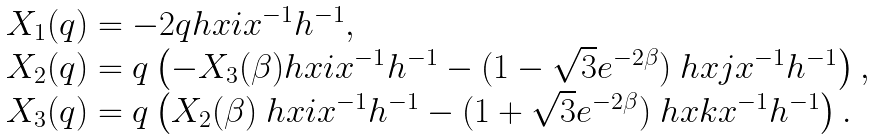<formula> <loc_0><loc_0><loc_500><loc_500>\begin{array} { l } X _ { 1 } ( q ) = - 2 q h x i x ^ { - 1 } h ^ { - 1 } , \\ X _ { 2 } ( q ) = q \left ( - X _ { 3 } ( \beta ) h x i x ^ { - 1 } h ^ { - 1 } - ( 1 - \sqrt { 3 } e ^ { - 2 \beta } ) \ h x j x ^ { - 1 } h ^ { - 1 } \right ) , \\ X _ { 3 } ( q ) = q \left ( X _ { 2 } ( \beta ) \ h x i x ^ { - 1 } h ^ { - 1 } - ( 1 + \sqrt { 3 } e ^ { - 2 \beta } ) \ h x k x ^ { - 1 } h ^ { - 1 } \right ) . \end{array}</formula> 